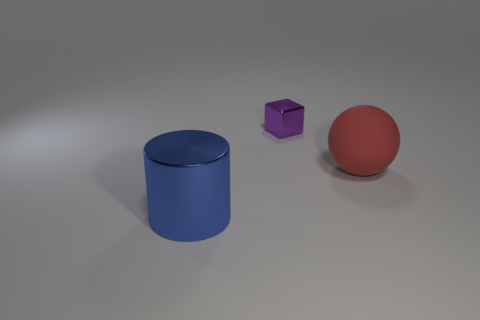Is there a yellow cube made of the same material as the large red ball?
Keep it short and to the point. No. What shape is the blue shiny thing?
Make the answer very short. Cylinder. There is a shiny object behind the big sphere that is to the right of the small shiny thing; what shape is it?
Ensure brevity in your answer.  Cube. How many other things are the same shape as the blue shiny thing?
Offer a very short reply. 0. What size is the metal thing to the right of the metallic object in front of the big matte sphere?
Provide a succinct answer. Small. Are there any small yellow cylinders?
Your answer should be very brief. No. There is a shiny object that is in front of the large red object; what number of blue cylinders are on the left side of it?
Give a very brief answer. 0. There is a metallic thing that is in front of the block; what shape is it?
Ensure brevity in your answer.  Cylinder. What is the material of the big cylinder in front of the large object that is to the right of the metal object in front of the large red rubber sphere?
Ensure brevity in your answer.  Metal. What number of other things are there of the same size as the red object?
Your answer should be compact. 1. 